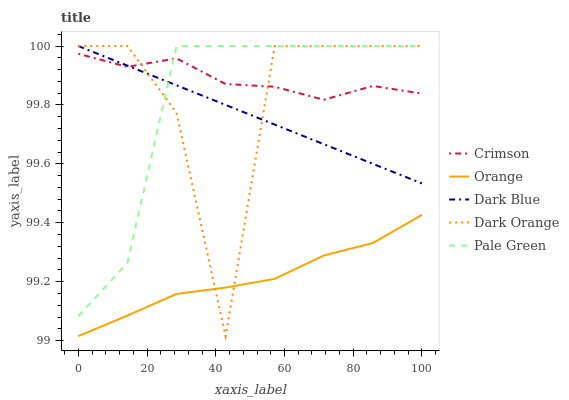Does Orange have the minimum area under the curve?
Answer yes or no. Yes. Does Crimson have the maximum area under the curve?
Answer yes or no. Yes. Does Pale Green have the minimum area under the curve?
Answer yes or no. No. Does Pale Green have the maximum area under the curve?
Answer yes or no. No. Is Dark Blue the smoothest?
Answer yes or no. Yes. Is Dark Orange the roughest?
Answer yes or no. Yes. Is Orange the smoothest?
Answer yes or no. No. Is Orange the roughest?
Answer yes or no. No. Does Orange have the lowest value?
Answer yes or no. No. Does Orange have the highest value?
Answer yes or no. No. Is Orange less than Crimson?
Answer yes or no. Yes. Is Dark Blue greater than Orange?
Answer yes or no. Yes. Does Orange intersect Crimson?
Answer yes or no. No. 